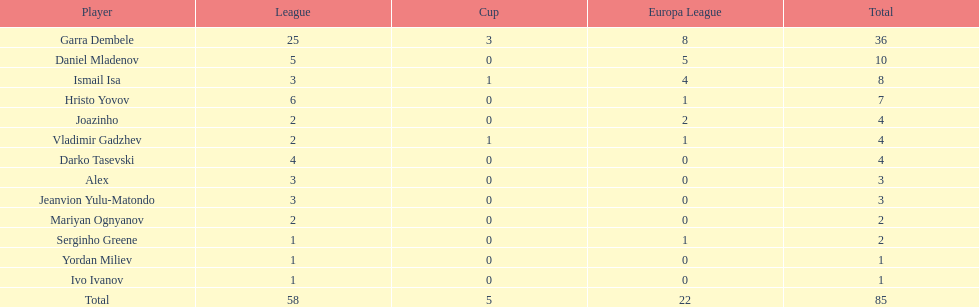Who was the top goalscorer on this team? Garra Dembele. 